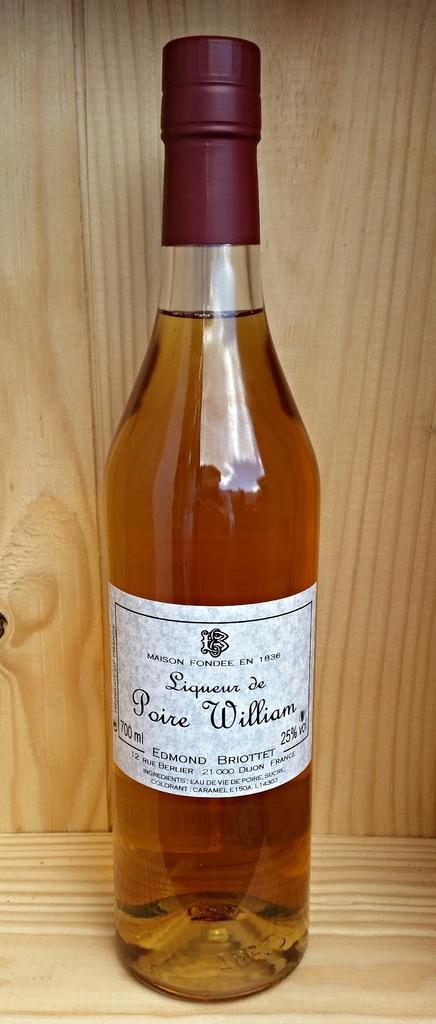In one or two sentences, can you explain what this image depicts? In this image i can see a bottle. 